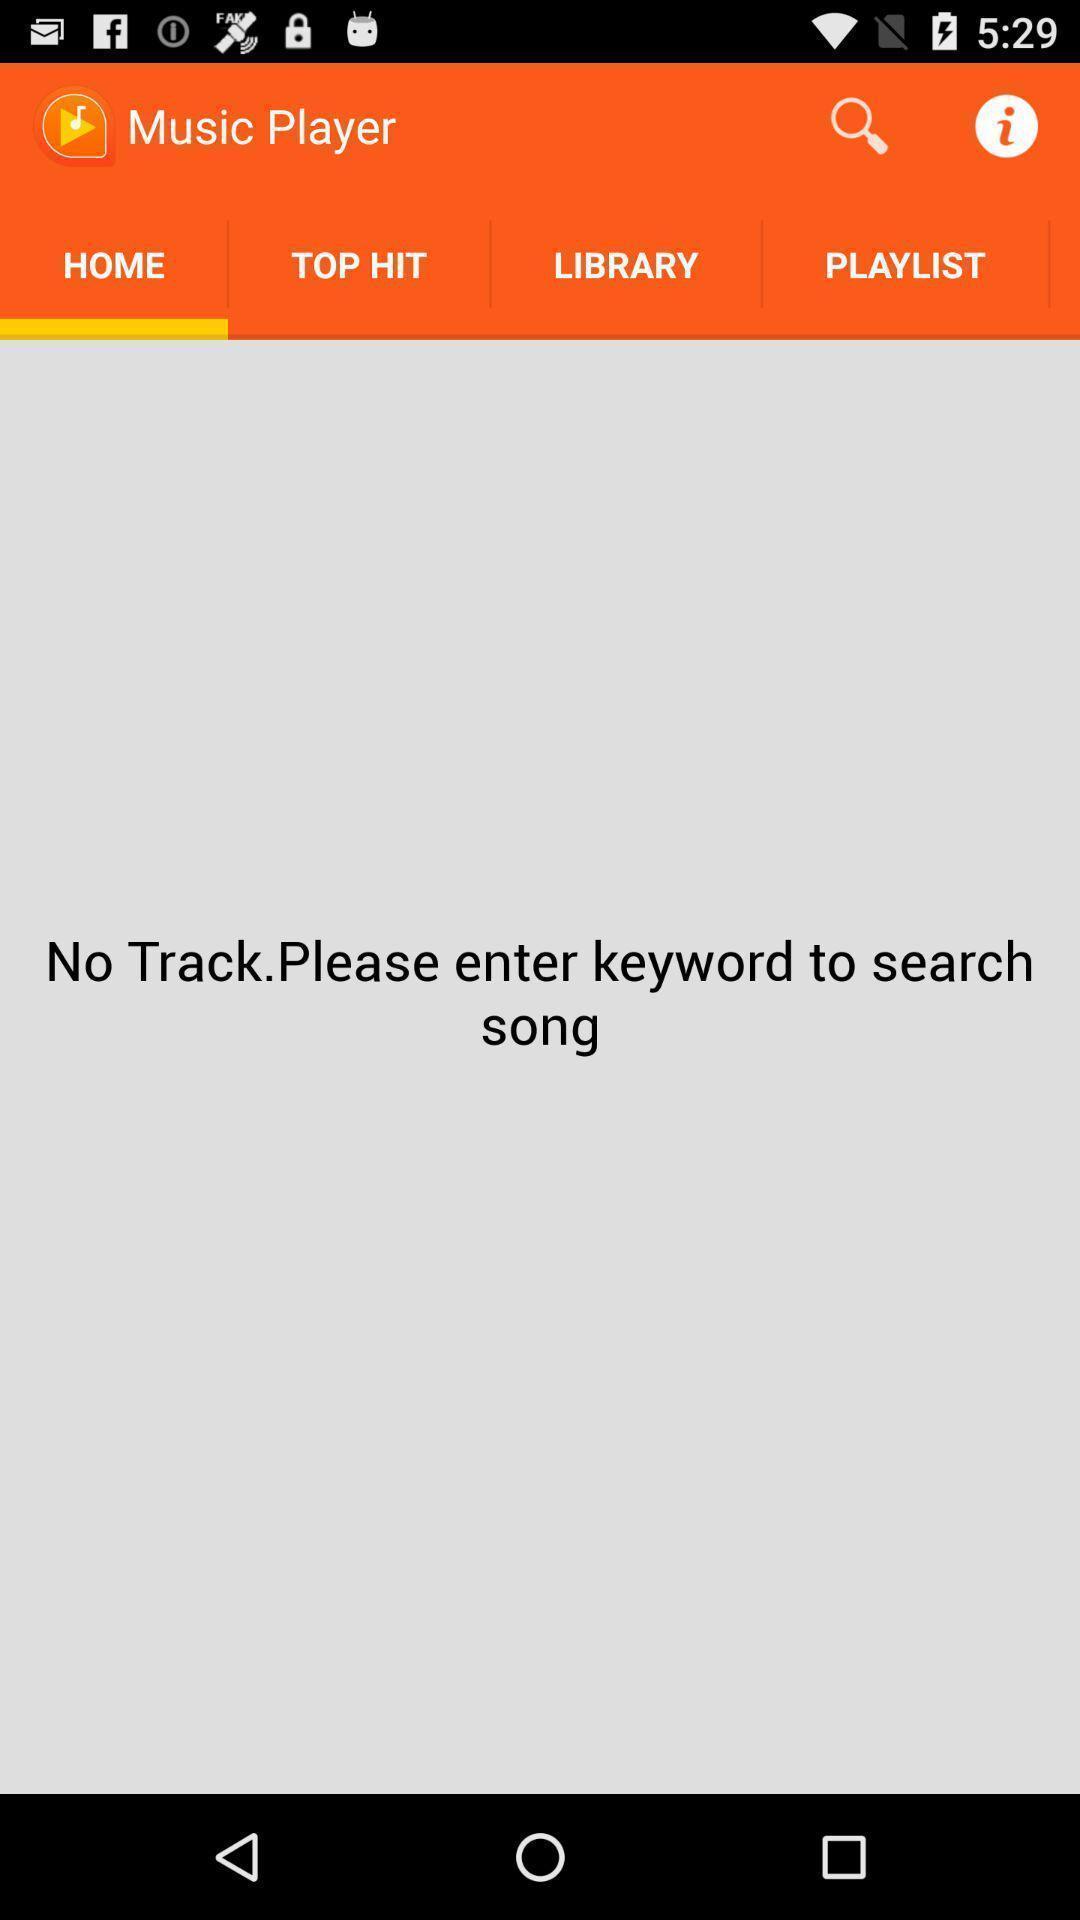Explain the elements present in this screenshot. Page requesting to enter keyword on a musical app. 